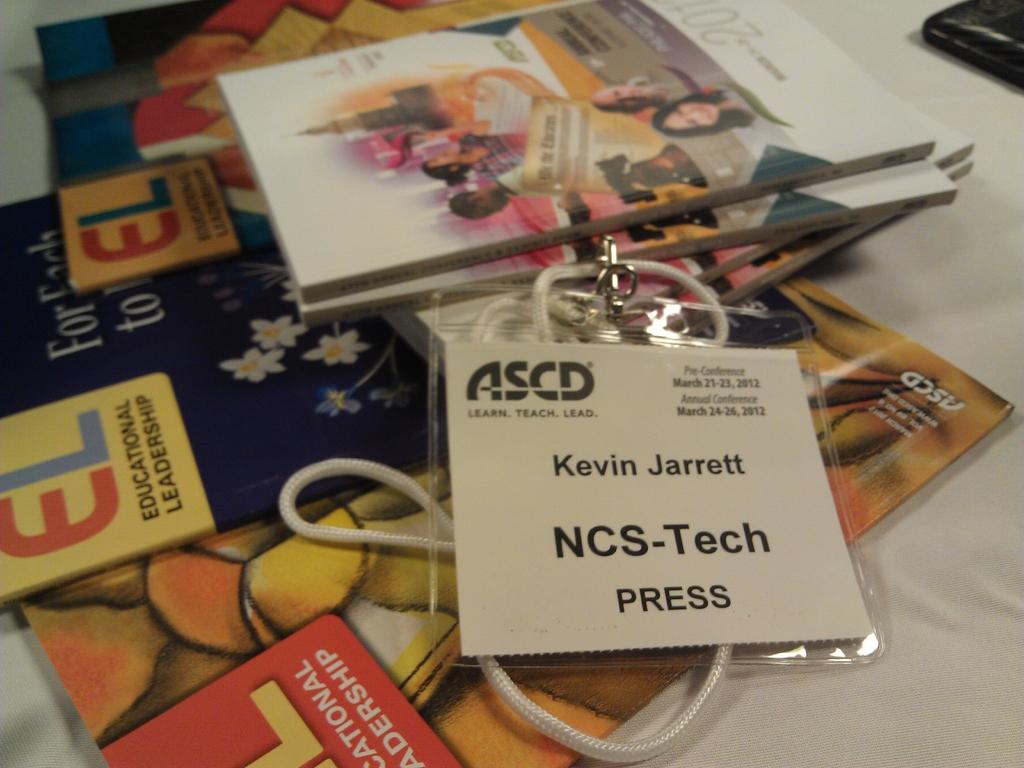What is kevin's title?
Give a very brief answer. Ncs-tech. 